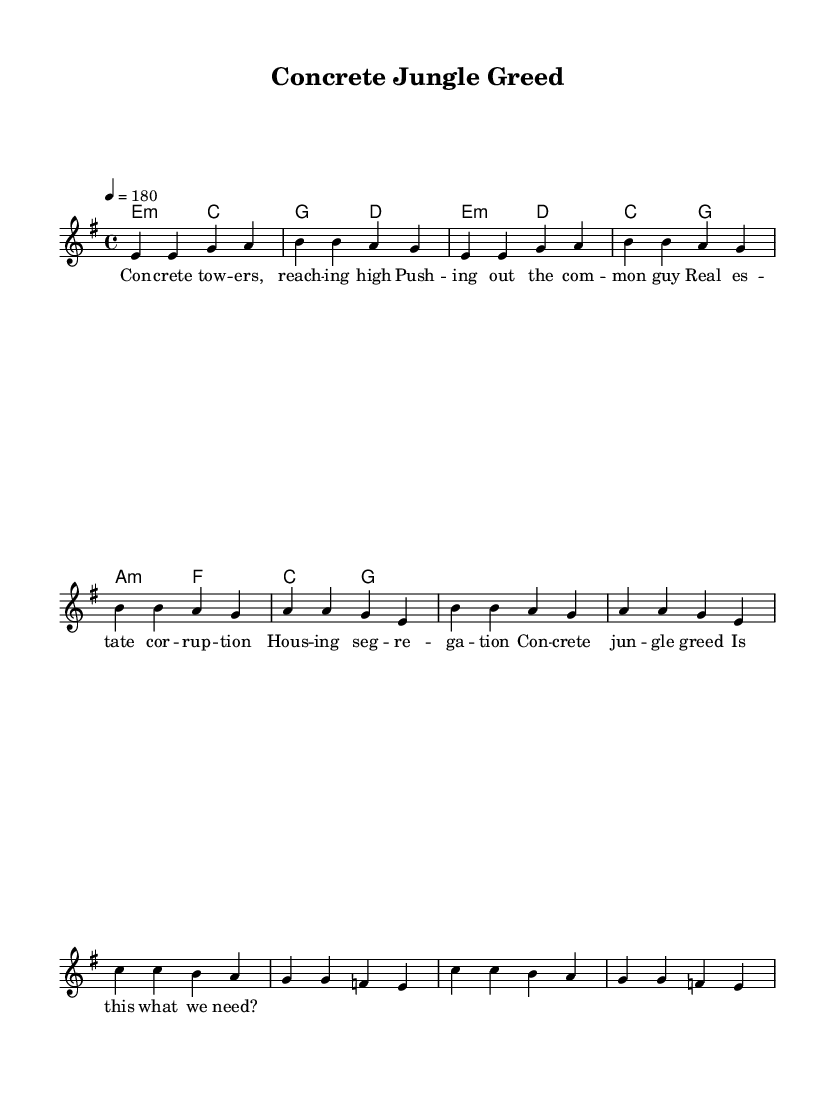What is the key signature of this music? The key signature is indicated in the global section, which shows it as E minor. E minor has one sharp (F#).
Answer: E minor What is the time signature of the piece? The time signature is also found in the global section and is marked as 4/4, meaning there are four beats in each measure and the quarter note receives one beat.
Answer: 4/4 What is the tempo marking for this piece? The tempo marking is found in the global section, which shows it as 4 = 180. This indicates that the piece should be played at 180 beats per minute.
Answer: 180 How many measures are in the verse section? By counting the measures indicated in the melody section, there are four measures in the verse, as outlined in the notes.
Answer: 4 What is the main theme of the lyrics? The lyrics criticize real estate practices and housing inequality, calling out issues like corruption and segregation. This theme is conveyed throughout the song's repeated phrasing.
Answer: Real estate corruption Which section contains the bridge? The bridge is explicitly labeled in the melody section and consists of a series of notes that follow the specified format. It appears after the chorus and is marked as a distinct musical phrase.
Answer: Bridge What type of chord progression does the chorus use? The chorus's chord progression can be identified in the harmonies section, showcasing a movement from E minor to D major, followed by C major and G major, highlighting a common punk sound.
Answer: E minor to D major to C major to G major 